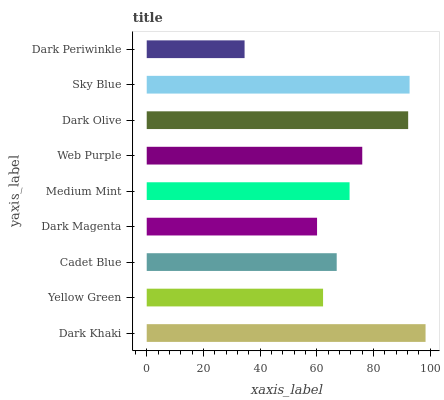Is Dark Periwinkle the minimum?
Answer yes or no. Yes. Is Dark Khaki the maximum?
Answer yes or no. Yes. Is Yellow Green the minimum?
Answer yes or no. No. Is Yellow Green the maximum?
Answer yes or no. No. Is Dark Khaki greater than Yellow Green?
Answer yes or no. Yes. Is Yellow Green less than Dark Khaki?
Answer yes or no. Yes. Is Yellow Green greater than Dark Khaki?
Answer yes or no. No. Is Dark Khaki less than Yellow Green?
Answer yes or no. No. Is Medium Mint the high median?
Answer yes or no. Yes. Is Medium Mint the low median?
Answer yes or no. Yes. Is Sky Blue the high median?
Answer yes or no. No. Is Dark Periwinkle the low median?
Answer yes or no. No. 